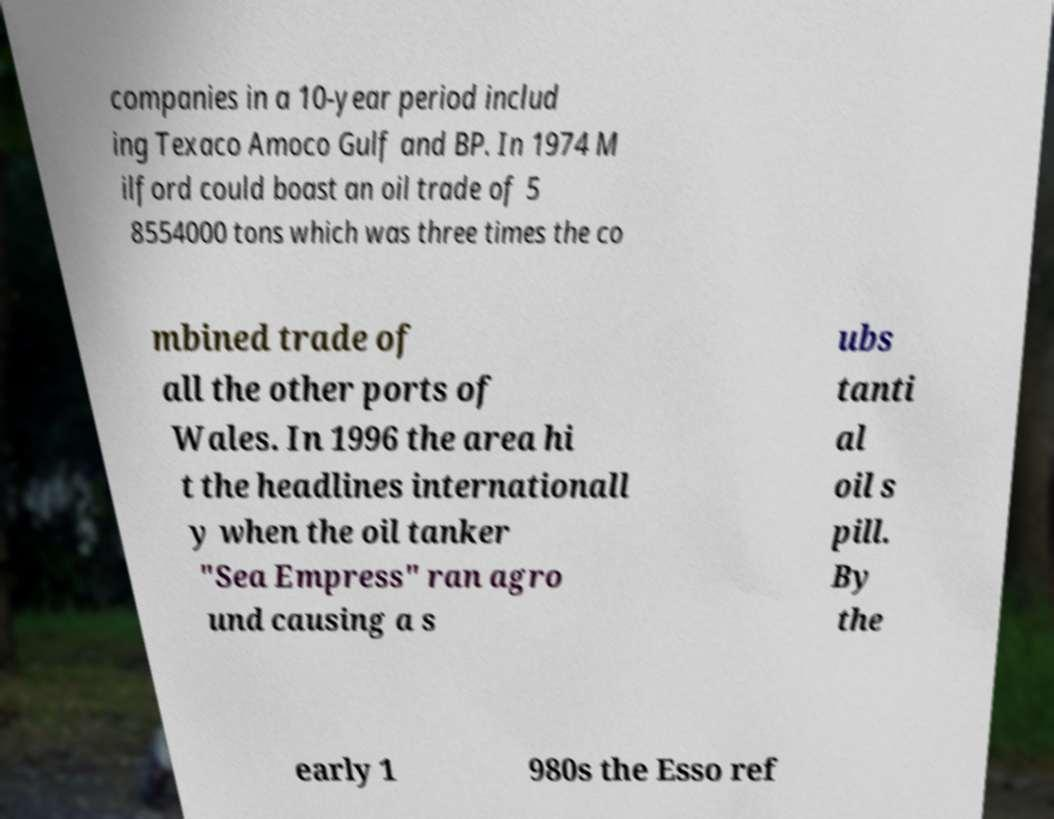I need the written content from this picture converted into text. Can you do that? companies in a 10-year period includ ing Texaco Amoco Gulf and BP. In 1974 M ilford could boast an oil trade of 5 8554000 tons which was three times the co mbined trade of all the other ports of Wales. In 1996 the area hi t the headlines internationall y when the oil tanker "Sea Empress" ran agro und causing a s ubs tanti al oil s pill. By the early 1 980s the Esso ref 